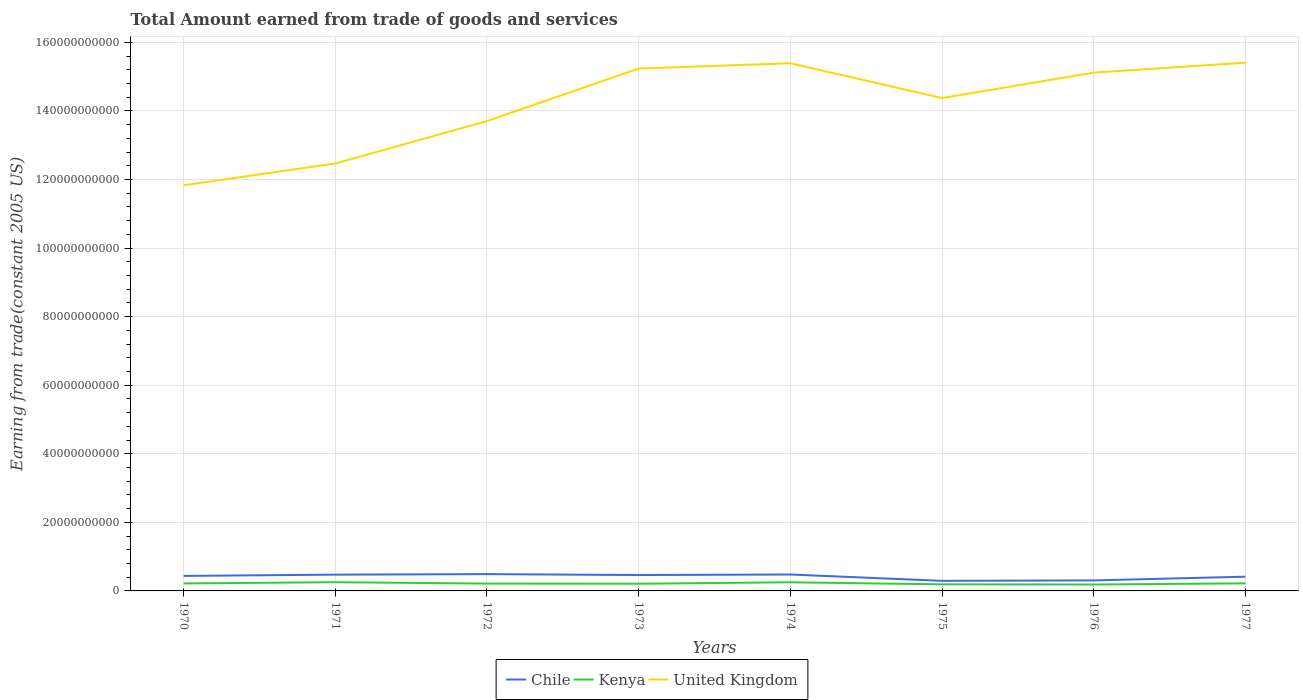How many different coloured lines are there?
Give a very brief answer. 3. Does the line corresponding to Chile intersect with the line corresponding to United Kingdom?
Ensure brevity in your answer.  No. Across all years, what is the maximum total amount earned by trading goods and services in United Kingdom?
Provide a short and direct response. 1.18e+11. In which year was the total amount earned by trading goods and services in Kenya maximum?
Provide a succinct answer. 1976. What is the total total amount earned by trading goods and services in Kenya in the graph?
Provide a succinct answer. 4.40e+08. What is the difference between the highest and the second highest total amount earned by trading goods and services in United Kingdom?
Keep it short and to the point. 3.58e+1. What is the difference between the highest and the lowest total amount earned by trading goods and services in United Kingdom?
Keep it short and to the point. 5. Is the total amount earned by trading goods and services in Kenya strictly greater than the total amount earned by trading goods and services in Chile over the years?
Provide a succinct answer. Yes. How many lines are there?
Provide a short and direct response. 3. How many years are there in the graph?
Provide a succinct answer. 8. What is the difference between two consecutive major ticks on the Y-axis?
Your answer should be compact. 2.00e+1. Does the graph contain any zero values?
Provide a short and direct response. No. Where does the legend appear in the graph?
Keep it short and to the point. Bottom center. How are the legend labels stacked?
Your answer should be very brief. Horizontal. What is the title of the graph?
Your response must be concise. Total Amount earned from trade of goods and services. Does "Slovenia" appear as one of the legend labels in the graph?
Ensure brevity in your answer.  No. What is the label or title of the X-axis?
Provide a succinct answer. Years. What is the label or title of the Y-axis?
Offer a terse response. Earning from trade(constant 2005 US). What is the Earning from trade(constant 2005 US) in Chile in 1970?
Offer a very short reply. 4.38e+09. What is the Earning from trade(constant 2005 US) of Kenya in 1970?
Give a very brief answer. 2.19e+09. What is the Earning from trade(constant 2005 US) of United Kingdom in 1970?
Your response must be concise. 1.18e+11. What is the Earning from trade(constant 2005 US) of Chile in 1971?
Your response must be concise. 4.75e+09. What is the Earning from trade(constant 2005 US) of Kenya in 1971?
Provide a succinct answer. 2.54e+09. What is the Earning from trade(constant 2005 US) in United Kingdom in 1971?
Offer a terse response. 1.25e+11. What is the Earning from trade(constant 2005 US) in Chile in 1972?
Provide a short and direct response. 4.90e+09. What is the Earning from trade(constant 2005 US) in Kenya in 1972?
Give a very brief answer. 2.14e+09. What is the Earning from trade(constant 2005 US) in United Kingdom in 1972?
Your response must be concise. 1.37e+11. What is the Earning from trade(constant 2005 US) of Chile in 1973?
Your response must be concise. 4.64e+09. What is the Earning from trade(constant 2005 US) of Kenya in 1973?
Your response must be concise. 2.10e+09. What is the Earning from trade(constant 2005 US) of United Kingdom in 1973?
Keep it short and to the point. 1.52e+11. What is the Earning from trade(constant 2005 US) of Chile in 1974?
Your response must be concise. 4.79e+09. What is the Earning from trade(constant 2005 US) of Kenya in 1974?
Your response must be concise. 2.52e+09. What is the Earning from trade(constant 2005 US) of United Kingdom in 1974?
Provide a succinct answer. 1.54e+11. What is the Earning from trade(constant 2005 US) in Chile in 1975?
Offer a very short reply. 2.94e+09. What is the Earning from trade(constant 2005 US) in Kenya in 1975?
Offer a terse response. 1.92e+09. What is the Earning from trade(constant 2005 US) of United Kingdom in 1975?
Provide a succinct answer. 1.44e+11. What is the Earning from trade(constant 2005 US) of Chile in 1976?
Ensure brevity in your answer.  3.06e+09. What is the Earning from trade(constant 2005 US) of Kenya in 1976?
Offer a very short reply. 1.87e+09. What is the Earning from trade(constant 2005 US) of United Kingdom in 1976?
Offer a very short reply. 1.51e+11. What is the Earning from trade(constant 2005 US) in Chile in 1977?
Keep it short and to the point. 4.15e+09. What is the Earning from trade(constant 2005 US) of Kenya in 1977?
Your answer should be very brief. 2.21e+09. What is the Earning from trade(constant 2005 US) of United Kingdom in 1977?
Keep it short and to the point. 1.54e+11. Across all years, what is the maximum Earning from trade(constant 2005 US) of Chile?
Your answer should be very brief. 4.90e+09. Across all years, what is the maximum Earning from trade(constant 2005 US) in Kenya?
Your answer should be compact. 2.54e+09. Across all years, what is the maximum Earning from trade(constant 2005 US) of United Kingdom?
Offer a very short reply. 1.54e+11. Across all years, what is the minimum Earning from trade(constant 2005 US) of Chile?
Provide a short and direct response. 2.94e+09. Across all years, what is the minimum Earning from trade(constant 2005 US) of Kenya?
Make the answer very short. 1.87e+09. Across all years, what is the minimum Earning from trade(constant 2005 US) of United Kingdom?
Provide a short and direct response. 1.18e+11. What is the total Earning from trade(constant 2005 US) of Chile in the graph?
Ensure brevity in your answer.  3.36e+1. What is the total Earning from trade(constant 2005 US) of Kenya in the graph?
Provide a short and direct response. 1.75e+1. What is the total Earning from trade(constant 2005 US) of United Kingdom in the graph?
Your answer should be very brief. 1.14e+12. What is the difference between the Earning from trade(constant 2005 US) in Chile in 1970 and that in 1971?
Your answer should be compact. -3.74e+08. What is the difference between the Earning from trade(constant 2005 US) of Kenya in 1970 and that in 1971?
Provide a short and direct response. -3.54e+08. What is the difference between the Earning from trade(constant 2005 US) in United Kingdom in 1970 and that in 1971?
Provide a short and direct response. -6.36e+09. What is the difference between the Earning from trade(constant 2005 US) of Chile in 1970 and that in 1972?
Keep it short and to the point. -5.23e+08. What is the difference between the Earning from trade(constant 2005 US) in Kenya in 1970 and that in 1972?
Your response must be concise. 5.26e+07. What is the difference between the Earning from trade(constant 2005 US) of United Kingdom in 1970 and that in 1972?
Offer a very short reply. -1.87e+1. What is the difference between the Earning from trade(constant 2005 US) in Chile in 1970 and that in 1973?
Ensure brevity in your answer.  -2.58e+08. What is the difference between the Earning from trade(constant 2005 US) of Kenya in 1970 and that in 1973?
Your answer should be compact. 8.56e+07. What is the difference between the Earning from trade(constant 2005 US) in United Kingdom in 1970 and that in 1973?
Offer a very short reply. -3.41e+1. What is the difference between the Earning from trade(constant 2005 US) in Chile in 1970 and that in 1974?
Provide a succinct answer. -4.14e+08. What is the difference between the Earning from trade(constant 2005 US) in Kenya in 1970 and that in 1974?
Offer a terse response. -3.32e+08. What is the difference between the Earning from trade(constant 2005 US) of United Kingdom in 1970 and that in 1974?
Ensure brevity in your answer.  -3.56e+1. What is the difference between the Earning from trade(constant 2005 US) in Chile in 1970 and that in 1975?
Give a very brief answer. 1.44e+09. What is the difference between the Earning from trade(constant 2005 US) in Kenya in 1970 and that in 1975?
Give a very brief answer. 2.68e+08. What is the difference between the Earning from trade(constant 2005 US) of United Kingdom in 1970 and that in 1975?
Provide a succinct answer. -2.54e+1. What is the difference between the Earning from trade(constant 2005 US) of Chile in 1970 and that in 1976?
Ensure brevity in your answer.  1.31e+09. What is the difference between the Earning from trade(constant 2005 US) of Kenya in 1970 and that in 1976?
Your answer should be compact. 3.19e+08. What is the difference between the Earning from trade(constant 2005 US) of United Kingdom in 1970 and that in 1976?
Your response must be concise. -3.29e+1. What is the difference between the Earning from trade(constant 2005 US) in Chile in 1970 and that in 1977?
Offer a very short reply. 2.24e+08. What is the difference between the Earning from trade(constant 2005 US) in Kenya in 1970 and that in 1977?
Make the answer very short. -2.34e+07. What is the difference between the Earning from trade(constant 2005 US) in United Kingdom in 1970 and that in 1977?
Make the answer very short. -3.58e+1. What is the difference between the Earning from trade(constant 2005 US) of Chile in 1971 and that in 1972?
Offer a very short reply. -1.50e+08. What is the difference between the Earning from trade(constant 2005 US) of Kenya in 1971 and that in 1972?
Your answer should be very brief. 4.07e+08. What is the difference between the Earning from trade(constant 2005 US) in United Kingdom in 1971 and that in 1972?
Offer a very short reply. -1.24e+1. What is the difference between the Earning from trade(constant 2005 US) of Chile in 1971 and that in 1973?
Your answer should be very brief. 1.15e+08. What is the difference between the Earning from trade(constant 2005 US) in Kenya in 1971 and that in 1973?
Ensure brevity in your answer.  4.40e+08. What is the difference between the Earning from trade(constant 2005 US) in United Kingdom in 1971 and that in 1973?
Ensure brevity in your answer.  -2.77e+1. What is the difference between the Earning from trade(constant 2005 US) of Chile in 1971 and that in 1974?
Make the answer very short. -4.06e+07. What is the difference between the Earning from trade(constant 2005 US) of Kenya in 1971 and that in 1974?
Make the answer very short. 2.20e+07. What is the difference between the Earning from trade(constant 2005 US) in United Kingdom in 1971 and that in 1974?
Your answer should be compact. -2.92e+1. What is the difference between the Earning from trade(constant 2005 US) in Chile in 1971 and that in 1975?
Offer a terse response. 1.81e+09. What is the difference between the Earning from trade(constant 2005 US) of Kenya in 1971 and that in 1975?
Give a very brief answer. 6.22e+08. What is the difference between the Earning from trade(constant 2005 US) of United Kingdom in 1971 and that in 1975?
Offer a very short reply. -1.91e+1. What is the difference between the Earning from trade(constant 2005 US) of Chile in 1971 and that in 1976?
Offer a terse response. 1.69e+09. What is the difference between the Earning from trade(constant 2005 US) of Kenya in 1971 and that in 1976?
Keep it short and to the point. 6.73e+08. What is the difference between the Earning from trade(constant 2005 US) in United Kingdom in 1971 and that in 1976?
Give a very brief answer. -2.65e+1. What is the difference between the Earning from trade(constant 2005 US) of Chile in 1971 and that in 1977?
Your response must be concise. 5.97e+08. What is the difference between the Earning from trade(constant 2005 US) of Kenya in 1971 and that in 1977?
Make the answer very short. 3.31e+08. What is the difference between the Earning from trade(constant 2005 US) in United Kingdom in 1971 and that in 1977?
Keep it short and to the point. -2.94e+1. What is the difference between the Earning from trade(constant 2005 US) of Chile in 1972 and that in 1973?
Your response must be concise. 2.65e+08. What is the difference between the Earning from trade(constant 2005 US) in Kenya in 1972 and that in 1973?
Give a very brief answer. 3.30e+07. What is the difference between the Earning from trade(constant 2005 US) in United Kingdom in 1972 and that in 1973?
Give a very brief answer. -1.53e+1. What is the difference between the Earning from trade(constant 2005 US) in Chile in 1972 and that in 1974?
Keep it short and to the point. 1.09e+08. What is the difference between the Earning from trade(constant 2005 US) of Kenya in 1972 and that in 1974?
Give a very brief answer. -3.85e+08. What is the difference between the Earning from trade(constant 2005 US) in United Kingdom in 1972 and that in 1974?
Give a very brief answer. -1.69e+1. What is the difference between the Earning from trade(constant 2005 US) in Chile in 1972 and that in 1975?
Provide a short and direct response. 1.96e+09. What is the difference between the Earning from trade(constant 2005 US) of Kenya in 1972 and that in 1975?
Give a very brief answer. 2.15e+08. What is the difference between the Earning from trade(constant 2005 US) of United Kingdom in 1972 and that in 1975?
Your response must be concise. -6.71e+09. What is the difference between the Earning from trade(constant 2005 US) of Chile in 1972 and that in 1976?
Give a very brief answer. 1.84e+09. What is the difference between the Earning from trade(constant 2005 US) in Kenya in 1972 and that in 1976?
Provide a succinct answer. 2.66e+08. What is the difference between the Earning from trade(constant 2005 US) of United Kingdom in 1972 and that in 1976?
Your answer should be very brief. -1.41e+1. What is the difference between the Earning from trade(constant 2005 US) of Chile in 1972 and that in 1977?
Provide a succinct answer. 7.47e+08. What is the difference between the Earning from trade(constant 2005 US) of Kenya in 1972 and that in 1977?
Give a very brief answer. -7.61e+07. What is the difference between the Earning from trade(constant 2005 US) in United Kingdom in 1972 and that in 1977?
Ensure brevity in your answer.  -1.70e+1. What is the difference between the Earning from trade(constant 2005 US) of Chile in 1973 and that in 1974?
Provide a short and direct response. -1.56e+08. What is the difference between the Earning from trade(constant 2005 US) of Kenya in 1973 and that in 1974?
Provide a succinct answer. -4.18e+08. What is the difference between the Earning from trade(constant 2005 US) in United Kingdom in 1973 and that in 1974?
Offer a very short reply. -1.53e+09. What is the difference between the Earning from trade(constant 2005 US) of Chile in 1973 and that in 1975?
Give a very brief answer. 1.70e+09. What is the difference between the Earning from trade(constant 2005 US) of Kenya in 1973 and that in 1975?
Your response must be concise. 1.82e+08. What is the difference between the Earning from trade(constant 2005 US) in United Kingdom in 1973 and that in 1975?
Ensure brevity in your answer.  8.62e+09. What is the difference between the Earning from trade(constant 2005 US) of Chile in 1973 and that in 1976?
Your answer should be compact. 1.57e+09. What is the difference between the Earning from trade(constant 2005 US) in Kenya in 1973 and that in 1976?
Your answer should be compact. 2.33e+08. What is the difference between the Earning from trade(constant 2005 US) of United Kingdom in 1973 and that in 1976?
Give a very brief answer. 1.20e+09. What is the difference between the Earning from trade(constant 2005 US) of Chile in 1973 and that in 1977?
Provide a short and direct response. 4.82e+08. What is the difference between the Earning from trade(constant 2005 US) in Kenya in 1973 and that in 1977?
Offer a very short reply. -1.09e+08. What is the difference between the Earning from trade(constant 2005 US) in United Kingdom in 1973 and that in 1977?
Ensure brevity in your answer.  -1.71e+09. What is the difference between the Earning from trade(constant 2005 US) in Chile in 1974 and that in 1975?
Provide a short and direct response. 1.85e+09. What is the difference between the Earning from trade(constant 2005 US) of Kenya in 1974 and that in 1975?
Make the answer very short. 6.00e+08. What is the difference between the Earning from trade(constant 2005 US) of United Kingdom in 1974 and that in 1975?
Your answer should be very brief. 1.01e+1. What is the difference between the Earning from trade(constant 2005 US) in Chile in 1974 and that in 1976?
Provide a succinct answer. 1.73e+09. What is the difference between the Earning from trade(constant 2005 US) in Kenya in 1974 and that in 1976?
Offer a very short reply. 6.51e+08. What is the difference between the Earning from trade(constant 2005 US) of United Kingdom in 1974 and that in 1976?
Provide a short and direct response. 2.73e+09. What is the difference between the Earning from trade(constant 2005 US) of Chile in 1974 and that in 1977?
Your answer should be very brief. 6.38e+08. What is the difference between the Earning from trade(constant 2005 US) in Kenya in 1974 and that in 1977?
Keep it short and to the point. 3.09e+08. What is the difference between the Earning from trade(constant 2005 US) in United Kingdom in 1974 and that in 1977?
Keep it short and to the point. -1.75e+08. What is the difference between the Earning from trade(constant 2005 US) in Chile in 1975 and that in 1976?
Keep it short and to the point. -1.26e+08. What is the difference between the Earning from trade(constant 2005 US) of Kenya in 1975 and that in 1976?
Provide a short and direct response. 5.09e+07. What is the difference between the Earning from trade(constant 2005 US) in United Kingdom in 1975 and that in 1976?
Offer a terse response. -7.42e+09. What is the difference between the Earning from trade(constant 2005 US) in Chile in 1975 and that in 1977?
Keep it short and to the point. -1.22e+09. What is the difference between the Earning from trade(constant 2005 US) in Kenya in 1975 and that in 1977?
Your response must be concise. -2.91e+08. What is the difference between the Earning from trade(constant 2005 US) of United Kingdom in 1975 and that in 1977?
Make the answer very short. -1.03e+1. What is the difference between the Earning from trade(constant 2005 US) of Chile in 1976 and that in 1977?
Keep it short and to the point. -1.09e+09. What is the difference between the Earning from trade(constant 2005 US) in Kenya in 1976 and that in 1977?
Offer a terse response. -3.42e+08. What is the difference between the Earning from trade(constant 2005 US) in United Kingdom in 1976 and that in 1977?
Offer a very short reply. -2.91e+09. What is the difference between the Earning from trade(constant 2005 US) of Chile in 1970 and the Earning from trade(constant 2005 US) of Kenya in 1971?
Provide a succinct answer. 1.84e+09. What is the difference between the Earning from trade(constant 2005 US) of Chile in 1970 and the Earning from trade(constant 2005 US) of United Kingdom in 1971?
Your answer should be compact. -1.20e+11. What is the difference between the Earning from trade(constant 2005 US) of Kenya in 1970 and the Earning from trade(constant 2005 US) of United Kingdom in 1971?
Provide a short and direct response. -1.23e+11. What is the difference between the Earning from trade(constant 2005 US) in Chile in 1970 and the Earning from trade(constant 2005 US) in Kenya in 1972?
Provide a succinct answer. 2.24e+09. What is the difference between the Earning from trade(constant 2005 US) of Chile in 1970 and the Earning from trade(constant 2005 US) of United Kingdom in 1972?
Offer a very short reply. -1.33e+11. What is the difference between the Earning from trade(constant 2005 US) of Kenya in 1970 and the Earning from trade(constant 2005 US) of United Kingdom in 1972?
Provide a short and direct response. -1.35e+11. What is the difference between the Earning from trade(constant 2005 US) of Chile in 1970 and the Earning from trade(constant 2005 US) of Kenya in 1973?
Give a very brief answer. 2.28e+09. What is the difference between the Earning from trade(constant 2005 US) of Chile in 1970 and the Earning from trade(constant 2005 US) of United Kingdom in 1973?
Ensure brevity in your answer.  -1.48e+11. What is the difference between the Earning from trade(constant 2005 US) in Kenya in 1970 and the Earning from trade(constant 2005 US) in United Kingdom in 1973?
Make the answer very short. -1.50e+11. What is the difference between the Earning from trade(constant 2005 US) in Chile in 1970 and the Earning from trade(constant 2005 US) in Kenya in 1974?
Your answer should be compact. 1.86e+09. What is the difference between the Earning from trade(constant 2005 US) of Chile in 1970 and the Earning from trade(constant 2005 US) of United Kingdom in 1974?
Your answer should be compact. -1.50e+11. What is the difference between the Earning from trade(constant 2005 US) of Kenya in 1970 and the Earning from trade(constant 2005 US) of United Kingdom in 1974?
Your answer should be very brief. -1.52e+11. What is the difference between the Earning from trade(constant 2005 US) of Chile in 1970 and the Earning from trade(constant 2005 US) of Kenya in 1975?
Offer a very short reply. 2.46e+09. What is the difference between the Earning from trade(constant 2005 US) of Chile in 1970 and the Earning from trade(constant 2005 US) of United Kingdom in 1975?
Offer a terse response. -1.39e+11. What is the difference between the Earning from trade(constant 2005 US) in Kenya in 1970 and the Earning from trade(constant 2005 US) in United Kingdom in 1975?
Give a very brief answer. -1.42e+11. What is the difference between the Earning from trade(constant 2005 US) in Chile in 1970 and the Earning from trade(constant 2005 US) in Kenya in 1976?
Make the answer very short. 2.51e+09. What is the difference between the Earning from trade(constant 2005 US) of Chile in 1970 and the Earning from trade(constant 2005 US) of United Kingdom in 1976?
Your answer should be very brief. -1.47e+11. What is the difference between the Earning from trade(constant 2005 US) in Kenya in 1970 and the Earning from trade(constant 2005 US) in United Kingdom in 1976?
Give a very brief answer. -1.49e+11. What is the difference between the Earning from trade(constant 2005 US) of Chile in 1970 and the Earning from trade(constant 2005 US) of Kenya in 1977?
Offer a terse response. 2.17e+09. What is the difference between the Earning from trade(constant 2005 US) of Chile in 1970 and the Earning from trade(constant 2005 US) of United Kingdom in 1977?
Provide a succinct answer. -1.50e+11. What is the difference between the Earning from trade(constant 2005 US) of Kenya in 1970 and the Earning from trade(constant 2005 US) of United Kingdom in 1977?
Your response must be concise. -1.52e+11. What is the difference between the Earning from trade(constant 2005 US) of Chile in 1971 and the Earning from trade(constant 2005 US) of Kenya in 1972?
Provide a succinct answer. 2.62e+09. What is the difference between the Earning from trade(constant 2005 US) of Chile in 1971 and the Earning from trade(constant 2005 US) of United Kingdom in 1972?
Your answer should be compact. -1.32e+11. What is the difference between the Earning from trade(constant 2005 US) of Kenya in 1971 and the Earning from trade(constant 2005 US) of United Kingdom in 1972?
Provide a short and direct response. -1.35e+11. What is the difference between the Earning from trade(constant 2005 US) in Chile in 1971 and the Earning from trade(constant 2005 US) in Kenya in 1973?
Give a very brief answer. 2.65e+09. What is the difference between the Earning from trade(constant 2005 US) in Chile in 1971 and the Earning from trade(constant 2005 US) in United Kingdom in 1973?
Offer a terse response. -1.48e+11. What is the difference between the Earning from trade(constant 2005 US) of Kenya in 1971 and the Earning from trade(constant 2005 US) of United Kingdom in 1973?
Give a very brief answer. -1.50e+11. What is the difference between the Earning from trade(constant 2005 US) of Chile in 1971 and the Earning from trade(constant 2005 US) of Kenya in 1974?
Your answer should be very brief. 2.23e+09. What is the difference between the Earning from trade(constant 2005 US) in Chile in 1971 and the Earning from trade(constant 2005 US) in United Kingdom in 1974?
Offer a very short reply. -1.49e+11. What is the difference between the Earning from trade(constant 2005 US) in Kenya in 1971 and the Earning from trade(constant 2005 US) in United Kingdom in 1974?
Provide a succinct answer. -1.51e+11. What is the difference between the Earning from trade(constant 2005 US) in Chile in 1971 and the Earning from trade(constant 2005 US) in Kenya in 1975?
Make the answer very short. 2.83e+09. What is the difference between the Earning from trade(constant 2005 US) of Chile in 1971 and the Earning from trade(constant 2005 US) of United Kingdom in 1975?
Provide a short and direct response. -1.39e+11. What is the difference between the Earning from trade(constant 2005 US) of Kenya in 1971 and the Earning from trade(constant 2005 US) of United Kingdom in 1975?
Provide a short and direct response. -1.41e+11. What is the difference between the Earning from trade(constant 2005 US) of Chile in 1971 and the Earning from trade(constant 2005 US) of Kenya in 1976?
Ensure brevity in your answer.  2.88e+09. What is the difference between the Earning from trade(constant 2005 US) of Chile in 1971 and the Earning from trade(constant 2005 US) of United Kingdom in 1976?
Provide a succinct answer. -1.46e+11. What is the difference between the Earning from trade(constant 2005 US) in Kenya in 1971 and the Earning from trade(constant 2005 US) in United Kingdom in 1976?
Make the answer very short. -1.49e+11. What is the difference between the Earning from trade(constant 2005 US) in Chile in 1971 and the Earning from trade(constant 2005 US) in Kenya in 1977?
Make the answer very short. 2.54e+09. What is the difference between the Earning from trade(constant 2005 US) of Chile in 1971 and the Earning from trade(constant 2005 US) of United Kingdom in 1977?
Give a very brief answer. -1.49e+11. What is the difference between the Earning from trade(constant 2005 US) of Kenya in 1971 and the Earning from trade(constant 2005 US) of United Kingdom in 1977?
Your answer should be very brief. -1.52e+11. What is the difference between the Earning from trade(constant 2005 US) of Chile in 1972 and the Earning from trade(constant 2005 US) of Kenya in 1973?
Ensure brevity in your answer.  2.80e+09. What is the difference between the Earning from trade(constant 2005 US) of Chile in 1972 and the Earning from trade(constant 2005 US) of United Kingdom in 1973?
Offer a very short reply. -1.47e+11. What is the difference between the Earning from trade(constant 2005 US) of Kenya in 1972 and the Earning from trade(constant 2005 US) of United Kingdom in 1973?
Make the answer very short. -1.50e+11. What is the difference between the Earning from trade(constant 2005 US) of Chile in 1972 and the Earning from trade(constant 2005 US) of Kenya in 1974?
Offer a terse response. 2.38e+09. What is the difference between the Earning from trade(constant 2005 US) in Chile in 1972 and the Earning from trade(constant 2005 US) in United Kingdom in 1974?
Offer a very short reply. -1.49e+11. What is the difference between the Earning from trade(constant 2005 US) in Kenya in 1972 and the Earning from trade(constant 2005 US) in United Kingdom in 1974?
Your response must be concise. -1.52e+11. What is the difference between the Earning from trade(constant 2005 US) in Chile in 1972 and the Earning from trade(constant 2005 US) in Kenya in 1975?
Make the answer very short. 2.98e+09. What is the difference between the Earning from trade(constant 2005 US) in Chile in 1972 and the Earning from trade(constant 2005 US) in United Kingdom in 1975?
Ensure brevity in your answer.  -1.39e+11. What is the difference between the Earning from trade(constant 2005 US) in Kenya in 1972 and the Earning from trade(constant 2005 US) in United Kingdom in 1975?
Your answer should be compact. -1.42e+11. What is the difference between the Earning from trade(constant 2005 US) in Chile in 1972 and the Earning from trade(constant 2005 US) in Kenya in 1976?
Keep it short and to the point. 3.03e+09. What is the difference between the Earning from trade(constant 2005 US) of Chile in 1972 and the Earning from trade(constant 2005 US) of United Kingdom in 1976?
Your answer should be very brief. -1.46e+11. What is the difference between the Earning from trade(constant 2005 US) of Kenya in 1972 and the Earning from trade(constant 2005 US) of United Kingdom in 1976?
Offer a very short reply. -1.49e+11. What is the difference between the Earning from trade(constant 2005 US) of Chile in 1972 and the Earning from trade(constant 2005 US) of Kenya in 1977?
Provide a short and direct response. 2.69e+09. What is the difference between the Earning from trade(constant 2005 US) of Chile in 1972 and the Earning from trade(constant 2005 US) of United Kingdom in 1977?
Make the answer very short. -1.49e+11. What is the difference between the Earning from trade(constant 2005 US) in Kenya in 1972 and the Earning from trade(constant 2005 US) in United Kingdom in 1977?
Provide a short and direct response. -1.52e+11. What is the difference between the Earning from trade(constant 2005 US) in Chile in 1973 and the Earning from trade(constant 2005 US) in Kenya in 1974?
Make the answer very short. 2.12e+09. What is the difference between the Earning from trade(constant 2005 US) in Chile in 1973 and the Earning from trade(constant 2005 US) in United Kingdom in 1974?
Make the answer very short. -1.49e+11. What is the difference between the Earning from trade(constant 2005 US) of Kenya in 1973 and the Earning from trade(constant 2005 US) of United Kingdom in 1974?
Make the answer very short. -1.52e+11. What is the difference between the Earning from trade(constant 2005 US) of Chile in 1973 and the Earning from trade(constant 2005 US) of Kenya in 1975?
Your answer should be compact. 2.72e+09. What is the difference between the Earning from trade(constant 2005 US) in Chile in 1973 and the Earning from trade(constant 2005 US) in United Kingdom in 1975?
Offer a terse response. -1.39e+11. What is the difference between the Earning from trade(constant 2005 US) in Kenya in 1973 and the Earning from trade(constant 2005 US) in United Kingdom in 1975?
Ensure brevity in your answer.  -1.42e+11. What is the difference between the Earning from trade(constant 2005 US) of Chile in 1973 and the Earning from trade(constant 2005 US) of Kenya in 1976?
Make the answer very short. 2.77e+09. What is the difference between the Earning from trade(constant 2005 US) in Chile in 1973 and the Earning from trade(constant 2005 US) in United Kingdom in 1976?
Keep it short and to the point. -1.47e+11. What is the difference between the Earning from trade(constant 2005 US) of Kenya in 1973 and the Earning from trade(constant 2005 US) of United Kingdom in 1976?
Offer a very short reply. -1.49e+11. What is the difference between the Earning from trade(constant 2005 US) of Chile in 1973 and the Earning from trade(constant 2005 US) of Kenya in 1977?
Provide a succinct answer. 2.42e+09. What is the difference between the Earning from trade(constant 2005 US) in Chile in 1973 and the Earning from trade(constant 2005 US) in United Kingdom in 1977?
Keep it short and to the point. -1.49e+11. What is the difference between the Earning from trade(constant 2005 US) in Kenya in 1973 and the Earning from trade(constant 2005 US) in United Kingdom in 1977?
Offer a terse response. -1.52e+11. What is the difference between the Earning from trade(constant 2005 US) of Chile in 1974 and the Earning from trade(constant 2005 US) of Kenya in 1975?
Your answer should be very brief. 2.87e+09. What is the difference between the Earning from trade(constant 2005 US) in Chile in 1974 and the Earning from trade(constant 2005 US) in United Kingdom in 1975?
Make the answer very short. -1.39e+11. What is the difference between the Earning from trade(constant 2005 US) in Kenya in 1974 and the Earning from trade(constant 2005 US) in United Kingdom in 1975?
Your answer should be very brief. -1.41e+11. What is the difference between the Earning from trade(constant 2005 US) in Chile in 1974 and the Earning from trade(constant 2005 US) in Kenya in 1976?
Provide a succinct answer. 2.92e+09. What is the difference between the Earning from trade(constant 2005 US) in Chile in 1974 and the Earning from trade(constant 2005 US) in United Kingdom in 1976?
Offer a terse response. -1.46e+11. What is the difference between the Earning from trade(constant 2005 US) in Kenya in 1974 and the Earning from trade(constant 2005 US) in United Kingdom in 1976?
Make the answer very short. -1.49e+11. What is the difference between the Earning from trade(constant 2005 US) of Chile in 1974 and the Earning from trade(constant 2005 US) of Kenya in 1977?
Ensure brevity in your answer.  2.58e+09. What is the difference between the Earning from trade(constant 2005 US) of Chile in 1974 and the Earning from trade(constant 2005 US) of United Kingdom in 1977?
Your response must be concise. -1.49e+11. What is the difference between the Earning from trade(constant 2005 US) in Kenya in 1974 and the Earning from trade(constant 2005 US) in United Kingdom in 1977?
Make the answer very short. -1.52e+11. What is the difference between the Earning from trade(constant 2005 US) of Chile in 1975 and the Earning from trade(constant 2005 US) of Kenya in 1976?
Offer a terse response. 1.07e+09. What is the difference between the Earning from trade(constant 2005 US) of Chile in 1975 and the Earning from trade(constant 2005 US) of United Kingdom in 1976?
Keep it short and to the point. -1.48e+11. What is the difference between the Earning from trade(constant 2005 US) in Kenya in 1975 and the Earning from trade(constant 2005 US) in United Kingdom in 1976?
Your answer should be compact. -1.49e+11. What is the difference between the Earning from trade(constant 2005 US) of Chile in 1975 and the Earning from trade(constant 2005 US) of Kenya in 1977?
Provide a short and direct response. 7.27e+08. What is the difference between the Earning from trade(constant 2005 US) of Chile in 1975 and the Earning from trade(constant 2005 US) of United Kingdom in 1977?
Give a very brief answer. -1.51e+11. What is the difference between the Earning from trade(constant 2005 US) in Kenya in 1975 and the Earning from trade(constant 2005 US) in United Kingdom in 1977?
Your answer should be compact. -1.52e+11. What is the difference between the Earning from trade(constant 2005 US) in Chile in 1976 and the Earning from trade(constant 2005 US) in Kenya in 1977?
Your answer should be compact. 8.54e+08. What is the difference between the Earning from trade(constant 2005 US) in Chile in 1976 and the Earning from trade(constant 2005 US) in United Kingdom in 1977?
Your response must be concise. -1.51e+11. What is the difference between the Earning from trade(constant 2005 US) of Kenya in 1976 and the Earning from trade(constant 2005 US) of United Kingdom in 1977?
Give a very brief answer. -1.52e+11. What is the average Earning from trade(constant 2005 US) of Chile per year?
Offer a terse response. 4.20e+09. What is the average Earning from trade(constant 2005 US) of Kenya per year?
Your response must be concise. 2.19e+09. What is the average Earning from trade(constant 2005 US) in United Kingdom per year?
Make the answer very short. 1.42e+11. In the year 1970, what is the difference between the Earning from trade(constant 2005 US) in Chile and Earning from trade(constant 2005 US) in Kenya?
Your answer should be very brief. 2.19e+09. In the year 1970, what is the difference between the Earning from trade(constant 2005 US) of Chile and Earning from trade(constant 2005 US) of United Kingdom?
Ensure brevity in your answer.  -1.14e+11. In the year 1970, what is the difference between the Earning from trade(constant 2005 US) in Kenya and Earning from trade(constant 2005 US) in United Kingdom?
Your response must be concise. -1.16e+11. In the year 1971, what is the difference between the Earning from trade(constant 2005 US) in Chile and Earning from trade(constant 2005 US) in Kenya?
Provide a succinct answer. 2.21e+09. In the year 1971, what is the difference between the Earning from trade(constant 2005 US) in Chile and Earning from trade(constant 2005 US) in United Kingdom?
Your answer should be compact. -1.20e+11. In the year 1971, what is the difference between the Earning from trade(constant 2005 US) in Kenya and Earning from trade(constant 2005 US) in United Kingdom?
Ensure brevity in your answer.  -1.22e+11. In the year 1972, what is the difference between the Earning from trade(constant 2005 US) in Chile and Earning from trade(constant 2005 US) in Kenya?
Give a very brief answer. 2.77e+09. In the year 1972, what is the difference between the Earning from trade(constant 2005 US) in Chile and Earning from trade(constant 2005 US) in United Kingdom?
Your response must be concise. -1.32e+11. In the year 1972, what is the difference between the Earning from trade(constant 2005 US) of Kenya and Earning from trade(constant 2005 US) of United Kingdom?
Your response must be concise. -1.35e+11. In the year 1973, what is the difference between the Earning from trade(constant 2005 US) in Chile and Earning from trade(constant 2005 US) in Kenya?
Ensure brevity in your answer.  2.53e+09. In the year 1973, what is the difference between the Earning from trade(constant 2005 US) in Chile and Earning from trade(constant 2005 US) in United Kingdom?
Make the answer very short. -1.48e+11. In the year 1973, what is the difference between the Earning from trade(constant 2005 US) in Kenya and Earning from trade(constant 2005 US) in United Kingdom?
Ensure brevity in your answer.  -1.50e+11. In the year 1974, what is the difference between the Earning from trade(constant 2005 US) of Chile and Earning from trade(constant 2005 US) of Kenya?
Your answer should be very brief. 2.27e+09. In the year 1974, what is the difference between the Earning from trade(constant 2005 US) in Chile and Earning from trade(constant 2005 US) in United Kingdom?
Offer a terse response. -1.49e+11. In the year 1974, what is the difference between the Earning from trade(constant 2005 US) in Kenya and Earning from trade(constant 2005 US) in United Kingdom?
Provide a succinct answer. -1.51e+11. In the year 1975, what is the difference between the Earning from trade(constant 2005 US) in Chile and Earning from trade(constant 2005 US) in Kenya?
Provide a short and direct response. 1.02e+09. In the year 1975, what is the difference between the Earning from trade(constant 2005 US) in Chile and Earning from trade(constant 2005 US) in United Kingdom?
Keep it short and to the point. -1.41e+11. In the year 1975, what is the difference between the Earning from trade(constant 2005 US) in Kenya and Earning from trade(constant 2005 US) in United Kingdom?
Make the answer very short. -1.42e+11. In the year 1976, what is the difference between the Earning from trade(constant 2005 US) in Chile and Earning from trade(constant 2005 US) in Kenya?
Your answer should be very brief. 1.20e+09. In the year 1976, what is the difference between the Earning from trade(constant 2005 US) in Chile and Earning from trade(constant 2005 US) in United Kingdom?
Provide a short and direct response. -1.48e+11. In the year 1976, what is the difference between the Earning from trade(constant 2005 US) of Kenya and Earning from trade(constant 2005 US) of United Kingdom?
Keep it short and to the point. -1.49e+11. In the year 1977, what is the difference between the Earning from trade(constant 2005 US) in Chile and Earning from trade(constant 2005 US) in Kenya?
Offer a terse response. 1.94e+09. In the year 1977, what is the difference between the Earning from trade(constant 2005 US) of Chile and Earning from trade(constant 2005 US) of United Kingdom?
Offer a terse response. -1.50e+11. In the year 1977, what is the difference between the Earning from trade(constant 2005 US) in Kenya and Earning from trade(constant 2005 US) in United Kingdom?
Make the answer very short. -1.52e+11. What is the ratio of the Earning from trade(constant 2005 US) of Chile in 1970 to that in 1971?
Offer a very short reply. 0.92. What is the ratio of the Earning from trade(constant 2005 US) in Kenya in 1970 to that in 1971?
Offer a very short reply. 0.86. What is the ratio of the Earning from trade(constant 2005 US) of United Kingdom in 1970 to that in 1971?
Offer a terse response. 0.95. What is the ratio of the Earning from trade(constant 2005 US) of Chile in 1970 to that in 1972?
Keep it short and to the point. 0.89. What is the ratio of the Earning from trade(constant 2005 US) in Kenya in 1970 to that in 1972?
Your answer should be compact. 1.02. What is the ratio of the Earning from trade(constant 2005 US) in United Kingdom in 1970 to that in 1972?
Keep it short and to the point. 0.86. What is the ratio of the Earning from trade(constant 2005 US) of Chile in 1970 to that in 1973?
Your response must be concise. 0.94. What is the ratio of the Earning from trade(constant 2005 US) in Kenya in 1970 to that in 1973?
Ensure brevity in your answer.  1.04. What is the ratio of the Earning from trade(constant 2005 US) in United Kingdom in 1970 to that in 1973?
Your answer should be compact. 0.78. What is the ratio of the Earning from trade(constant 2005 US) in Chile in 1970 to that in 1974?
Keep it short and to the point. 0.91. What is the ratio of the Earning from trade(constant 2005 US) in Kenya in 1970 to that in 1974?
Offer a terse response. 0.87. What is the ratio of the Earning from trade(constant 2005 US) in United Kingdom in 1970 to that in 1974?
Your response must be concise. 0.77. What is the ratio of the Earning from trade(constant 2005 US) of Chile in 1970 to that in 1975?
Your answer should be compact. 1.49. What is the ratio of the Earning from trade(constant 2005 US) in Kenya in 1970 to that in 1975?
Offer a terse response. 1.14. What is the ratio of the Earning from trade(constant 2005 US) in United Kingdom in 1970 to that in 1975?
Offer a terse response. 0.82. What is the ratio of the Earning from trade(constant 2005 US) of Chile in 1970 to that in 1976?
Ensure brevity in your answer.  1.43. What is the ratio of the Earning from trade(constant 2005 US) in Kenya in 1970 to that in 1976?
Provide a short and direct response. 1.17. What is the ratio of the Earning from trade(constant 2005 US) of United Kingdom in 1970 to that in 1976?
Keep it short and to the point. 0.78. What is the ratio of the Earning from trade(constant 2005 US) in Chile in 1970 to that in 1977?
Ensure brevity in your answer.  1.05. What is the ratio of the Earning from trade(constant 2005 US) of Kenya in 1970 to that in 1977?
Your answer should be compact. 0.99. What is the ratio of the Earning from trade(constant 2005 US) in United Kingdom in 1970 to that in 1977?
Provide a short and direct response. 0.77. What is the ratio of the Earning from trade(constant 2005 US) in Chile in 1971 to that in 1972?
Give a very brief answer. 0.97. What is the ratio of the Earning from trade(constant 2005 US) of Kenya in 1971 to that in 1972?
Your response must be concise. 1.19. What is the ratio of the Earning from trade(constant 2005 US) in United Kingdom in 1971 to that in 1972?
Keep it short and to the point. 0.91. What is the ratio of the Earning from trade(constant 2005 US) in Chile in 1971 to that in 1973?
Keep it short and to the point. 1.02. What is the ratio of the Earning from trade(constant 2005 US) in Kenya in 1971 to that in 1973?
Provide a short and direct response. 1.21. What is the ratio of the Earning from trade(constant 2005 US) in United Kingdom in 1971 to that in 1973?
Offer a terse response. 0.82. What is the ratio of the Earning from trade(constant 2005 US) of Chile in 1971 to that in 1974?
Offer a terse response. 0.99. What is the ratio of the Earning from trade(constant 2005 US) of Kenya in 1971 to that in 1974?
Provide a succinct answer. 1.01. What is the ratio of the Earning from trade(constant 2005 US) in United Kingdom in 1971 to that in 1974?
Your answer should be very brief. 0.81. What is the ratio of the Earning from trade(constant 2005 US) of Chile in 1971 to that in 1975?
Provide a succinct answer. 1.62. What is the ratio of the Earning from trade(constant 2005 US) in Kenya in 1971 to that in 1975?
Offer a terse response. 1.32. What is the ratio of the Earning from trade(constant 2005 US) of United Kingdom in 1971 to that in 1975?
Provide a short and direct response. 0.87. What is the ratio of the Earning from trade(constant 2005 US) in Chile in 1971 to that in 1976?
Offer a very short reply. 1.55. What is the ratio of the Earning from trade(constant 2005 US) in Kenya in 1971 to that in 1976?
Your answer should be compact. 1.36. What is the ratio of the Earning from trade(constant 2005 US) of United Kingdom in 1971 to that in 1976?
Ensure brevity in your answer.  0.82. What is the ratio of the Earning from trade(constant 2005 US) in Chile in 1971 to that in 1977?
Your answer should be very brief. 1.14. What is the ratio of the Earning from trade(constant 2005 US) of Kenya in 1971 to that in 1977?
Offer a terse response. 1.15. What is the ratio of the Earning from trade(constant 2005 US) in United Kingdom in 1971 to that in 1977?
Provide a succinct answer. 0.81. What is the ratio of the Earning from trade(constant 2005 US) in Chile in 1972 to that in 1973?
Give a very brief answer. 1.06. What is the ratio of the Earning from trade(constant 2005 US) in Kenya in 1972 to that in 1973?
Your answer should be compact. 1.02. What is the ratio of the Earning from trade(constant 2005 US) of United Kingdom in 1972 to that in 1973?
Your answer should be compact. 0.9. What is the ratio of the Earning from trade(constant 2005 US) of Chile in 1972 to that in 1974?
Make the answer very short. 1.02. What is the ratio of the Earning from trade(constant 2005 US) in Kenya in 1972 to that in 1974?
Provide a short and direct response. 0.85. What is the ratio of the Earning from trade(constant 2005 US) in United Kingdom in 1972 to that in 1974?
Keep it short and to the point. 0.89. What is the ratio of the Earning from trade(constant 2005 US) in Chile in 1972 to that in 1975?
Offer a terse response. 1.67. What is the ratio of the Earning from trade(constant 2005 US) in Kenya in 1972 to that in 1975?
Offer a terse response. 1.11. What is the ratio of the Earning from trade(constant 2005 US) of United Kingdom in 1972 to that in 1975?
Offer a very short reply. 0.95. What is the ratio of the Earning from trade(constant 2005 US) in Chile in 1972 to that in 1976?
Ensure brevity in your answer.  1.6. What is the ratio of the Earning from trade(constant 2005 US) in Kenya in 1972 to that in 1976?
Your answer should be compact. 1.14. What is the ratio of the Earning from trade(constant 2005 US) in United Kingdom in 1972 to that in 1976?
Your answer should be very brief. 0.91. What is the ratio of the Earning from trade(constant 2005 US) of Chile in 1972 to that in 1977?
Give a very brief answer. 1.18. What is the ratio of the Earning from trade(constant 2005 US) in Kenya in 1972 to that in 1977?
Your response must be concise. 0.97. What is the ratio of the Earning from trade(constant 2005 US) in United Kingdom in 1972 to that in 1977?
Make the answer very short. 0.89. What is the ratio of the Earning from trade(constant 2005 US) of Chile in 1973 to that in 1974?
Keep it short and to the point. 0.97. What is the ratio of the Earning from trade(constant 2005 US) of Kenya in 1973 to that in 1974?
Offer a very short reply. 0.83. What is the ratio of the Earning from trade(constant 2005 US) of United Kingdom in 1973 to that in 1974?
Your response must be concise. 0.99. What is the ratio of the Earning from trade(constant 2005 US) of Chile in 1973 to that in 1975?
Your answer should be compact. 1.58. What is the ratio of the Earning from trade(constant 2005 US) of Kenya in 1973 to that in 1975?
Keep it short and to the point. 1.09. What is the ratio of the Earning from trade(constant 2005 US) of United Kingdom in 1973 to that in 1975?
Give a very brief answer. 1.06. What is the ratio of the Earning from trade(constant 2005 US) in Chile in 1973 to that in 1976?
Your answer should be compact. 1.51. What is the ratio of the Earning from trade(constant 2005 US) in Kenya in 1973 to that in 1976?
Provide a short and direct response. 1.12. What is the ratio of the Earning from trade(constant 2005 US) in United Kingdom in 1973 to that in 1976?
Keep it short and to the point. 1.01. What is the ratio of the Earning from trade(constant 2005 US) of Chile in 1973 to that in 1977?
Offer a terse response. 1.12. What is the ratio of the Earning from trade(constant 2005 US) of Kenya in 1973 to that in 1977?
Your answer should be compact. 0.95. What is the ratio of the Earning from trade(constant 2005 US) of United Kingdom in 1973 to that in 1977?
Provide a succinct answer. 0.99. What is the ratio of the Earning from trade(constant 2005 US) of Chile in 1974 to that in 1975?
Provide a succinct answer. 1.63. What is the ratio of the Earning from trade(constant 2005 US) in Kenya in 1974 to that in 1975?
Your answer should be very brief. 1.31. What is the ratio of the Earning from trade(constant 2005 US) of United Kingdom in 1974 to that in 1975?
Your answer should be compact. 1.07. What is the ratio of the Earning from trade(constant 2005 US) of Chile in 1974 to that in 1976?
Your answer should be compact. 1.56. What is the ratio of the Earning from trade(constant 2005 US) in Kenya in 1974 to that in 1976?
Offer a terse response. 1.35. What is the ratio of the Earning from trade(constant 2005 US) in United Kingdom in 1974 to that in 1976?
Ensure brevity in your answer.  1.02. What is the ratio of the Earning from trade(constant 2005 US) of Chile in 1974 to that in 1977?
Keep it short and to the point. 1.15. What is the ratio of the Earning from trade(constant 2005 US) of Kenya in 1974 to that in 1977?
Provide a succinct answer. 1.14. What is the ratio of the Earning from trade(constant 2005 US) in Chile in 1975 to that in 1976?
Offer a very short reply. 0.96. What is the ratio of the Earning from trade(constant 2005 US) of Kenya in 1975 to that in 1976?
Offer a terse response. 1.03. What is the ratio of the Earning from trade(constant 2005 US) in United Kingdom in 1975 to that in 1976?
Your answer should be compact. 0.95. What is the ratio of the Earning from trade(constant 2005 US) in Chile in 1975 to that in 1977?
Offer a very short reply. 0.71. What is the ratio of the Earning from trade(constant 2005 US) in Kenya in 1975 to that in 1977?
Offer a very short reply. 0.87. What is the ratio of the Earning from trade(constant 2005 US) of United Kingdom in 1975 to that in 1977?
Your answer should be very brief. 0.93. What is the ratio of the Earning from trade(constant 2005 US) in Chile in 1976 to that in 1977?
Provide a short and direct response. 0.74. What is the ratio of the Earning from trade(constant 2005 US) of Kenya in 1976 to that in 1977?
Keep it short and to the point. 0.85. What is the ratio of the Earning from trade(constant 2005 US) in United Kingdom in 1976 to that in 1977?
Your answer should be compact. 0.98. What is the difference between the highest and the second highest Earning from trade(constant 2005 US) of Chile?
Your answer should be very brief. 1.09e+08. What is the difference between the highest and the second highest Earning from trade(constant 2005 US) in Kenya?
Give a very brief answer. 2.20e+07. What is the difference between the highest and the second highest Earning from trade(constant 2005 US) in United Kingdom?
Keep it short and to the point. 1.75e+08. What is the difference between the highest and the lowest Earning from trade(constant 2005 US) in Chile?
Provide a short and direct response. 1.96e+09. What is the difference between the highest and the lowest Earning from trade(constant 2005 US) in Kenya?
Your response must be concise. 6.73e+08. What is the difference between the highest and the lowest Earning from trade(constant 2005 US) of United Kingdom?
Offer a very short reply. 3.58e+1. 